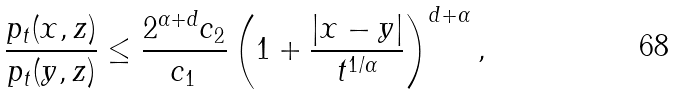Convert formula to latex. <formula><loc_0><loc_0><loc_500><loc_500>\frac { p _ { t } ( x , z ) } { p _ { t } ( y , z ) } \leq \frac { 2 ^ { \alpha + d } c _ { 2 } } { c _ { 1 } } \left ( 1 + \frac { | x - y | } { t ^ { 1 / \alpha } } \right ) ^ { d + \alpha } ,</formula> 